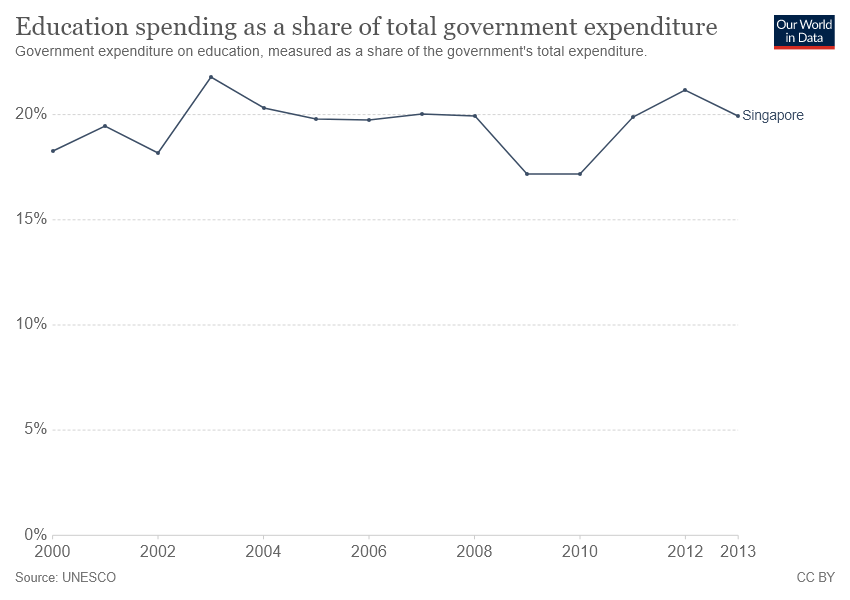Give some essential details in this illustration. Of the recorded data points, three exceeded 20%. The line graph indicates that Singapore is the country represented. 